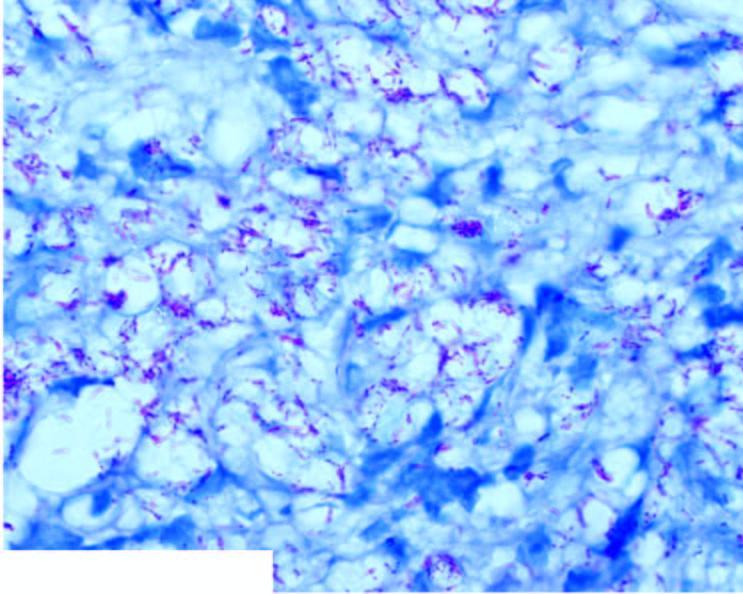s epra bacilli in ll seen in fite-faraco stain as globi and cigarettes-in-a-pack appearance inside the foam macrophages?
Answer the question using a single word or phrase. Yes 